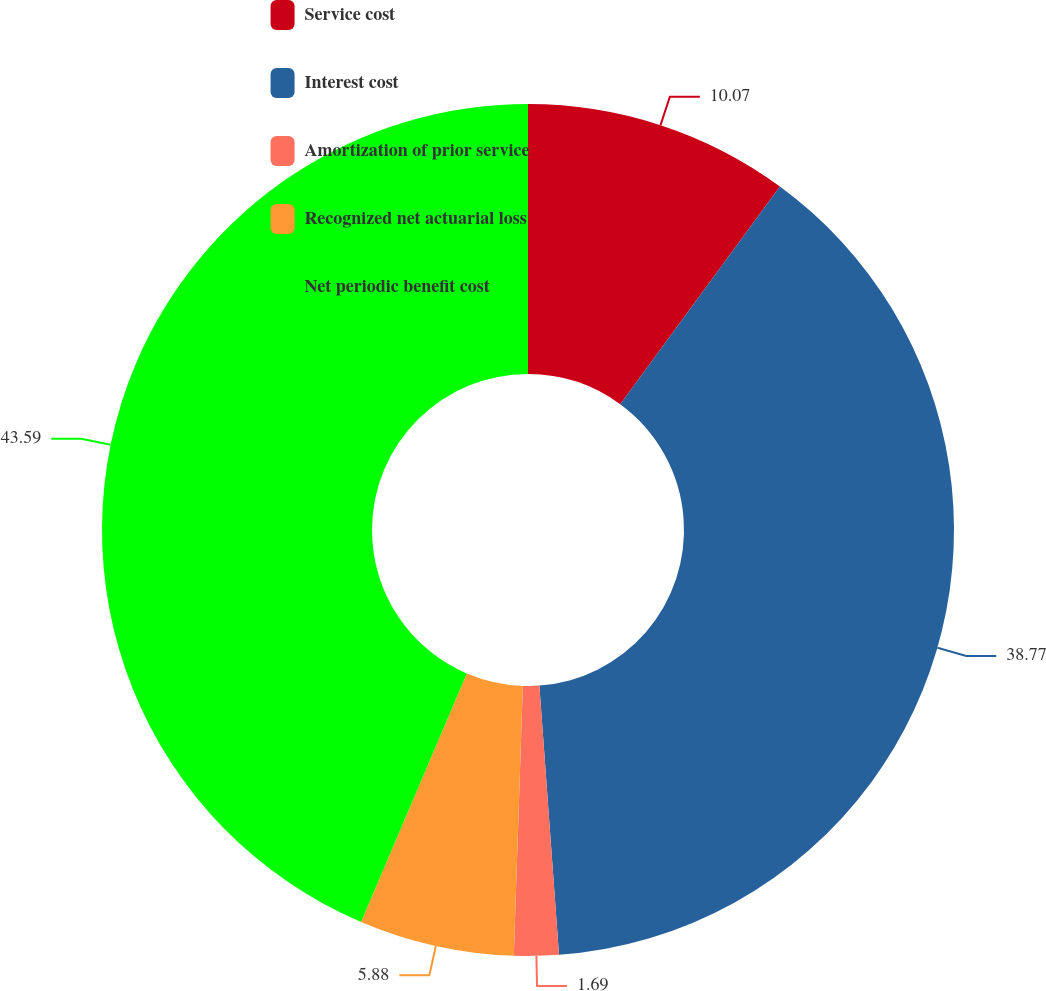Convert chart to OTSL. <chart><loc_0><loc_0><loc_500><loc_500><pie_chart><fcel>Service cost<fcel>Interest cost<fcel>Amortization of prior service<fcel>Recognized net actuarial loss<fcel>Net periodic benefit cost<nl><fcel>10.07%<fcel>38.77%<fcel>1.69%<fcel>5.88%<fcel>43.59%<nl></chart> 